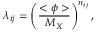<formula> <loc_0><loc_0><loc_500><loc_500>\lambda _ { i j } = \left ( { \frac { < \phi > } { M _ { X } } } \right ) ^ { n _ { i j } } ,</formula> 